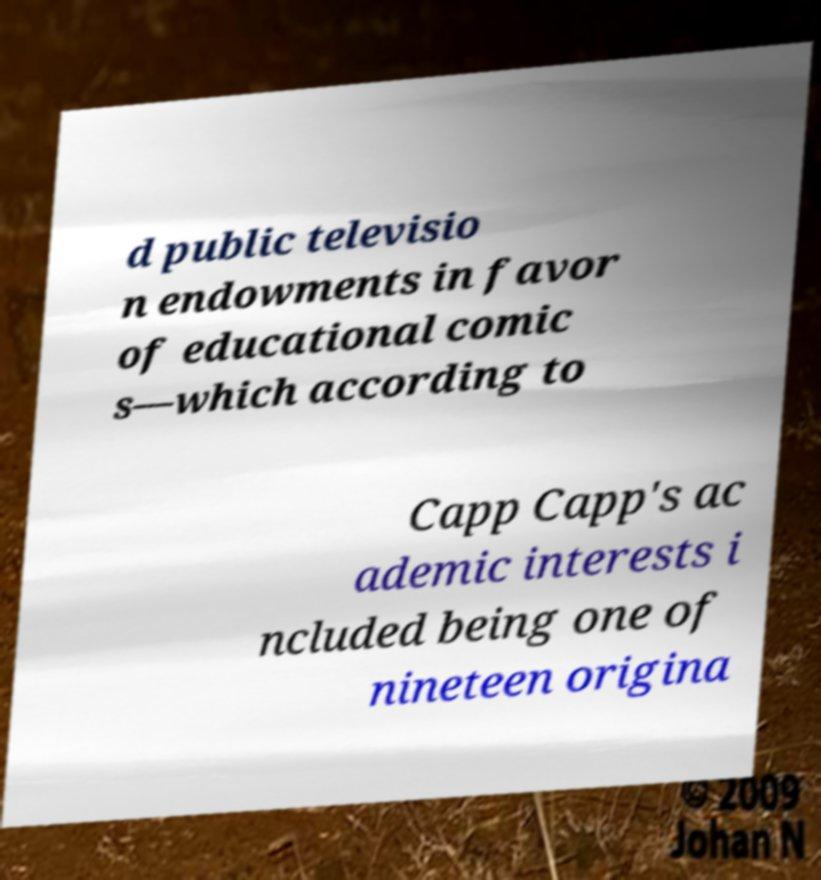For documentation purposes, I need the text within this image transcribed. Could you provide that? d public televisio n endowments in favor of educational comic s—which according to Capp Capp's ac ademic interests i ncluded being one of nineteen origina 